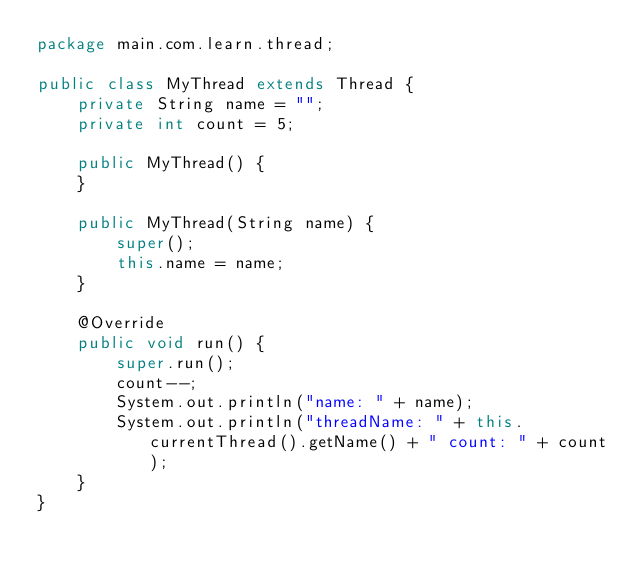<code> <loc_0><loc_0><loc_500><loc_500><_Java_>package main.com.learn.thread;

public class MyThread extends Thread {
    private String name = "";
    private int count = 5;

    public MyThread() {
    }

    public MyThread(String name) {
        super();
        this.name = name;
    }

    @Override
    public void run() {
        super.run();
        count--;
        System.out.println("name: " + name);
        System.out.println("threadName: " + this.currentThread().getName() + " count: " + count);
    }
}
</code> 